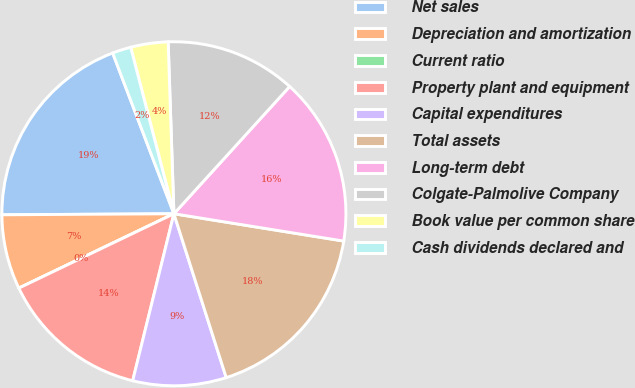Convert chart. <chart><loc_0><loc_0><loc_500><loc_500><pie_chart><fcel>Net sales<fcel>Depreciation and amortization<fcel>Current ratio<fcel>Property plant and equipment<fcel>Capital expenditures<fcel>Total assets<fcel>Long-term debt<fcel>Colgate-Palmolive Company<fcel>Book value per common share<fcel>Cash dividends declared and<nl><fcel>19.3%<fcel>7.02%<fcel>0.0%<fcel>14.03%<fcel>8.77%<fcel>17.54%<fcel>15.79%<fcel>12.28%<fcel>3.51%<fcel>1.75%<nl></chart> 